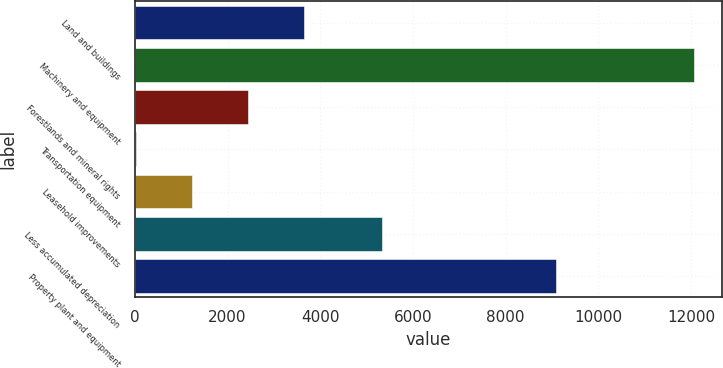Convert chart to OTSL. <chart><loc_0><loc_0><loc_500><loc_500><bar_chart><fcel>Land and buildings<fcel>Machinery and equipment<fcel>Forestlands and mineral rights<fcel>Transportation equipment<fcel>Leasehold improvements<fcel>Less accumulated depreciation<fcel>Property plant and equipment<nl><fcel>3640.27<fcel>12064<fcel>2436.88<fcel>30.1<fcel>1233.49<fcel>5337.4<fcel>9082.5<nl></chart> 